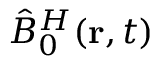<formula> <loc_0><loc_0><loc_500><loc_500>\hat { B } _ { 0 } ^ { H } ( { r } , t )</formula> 